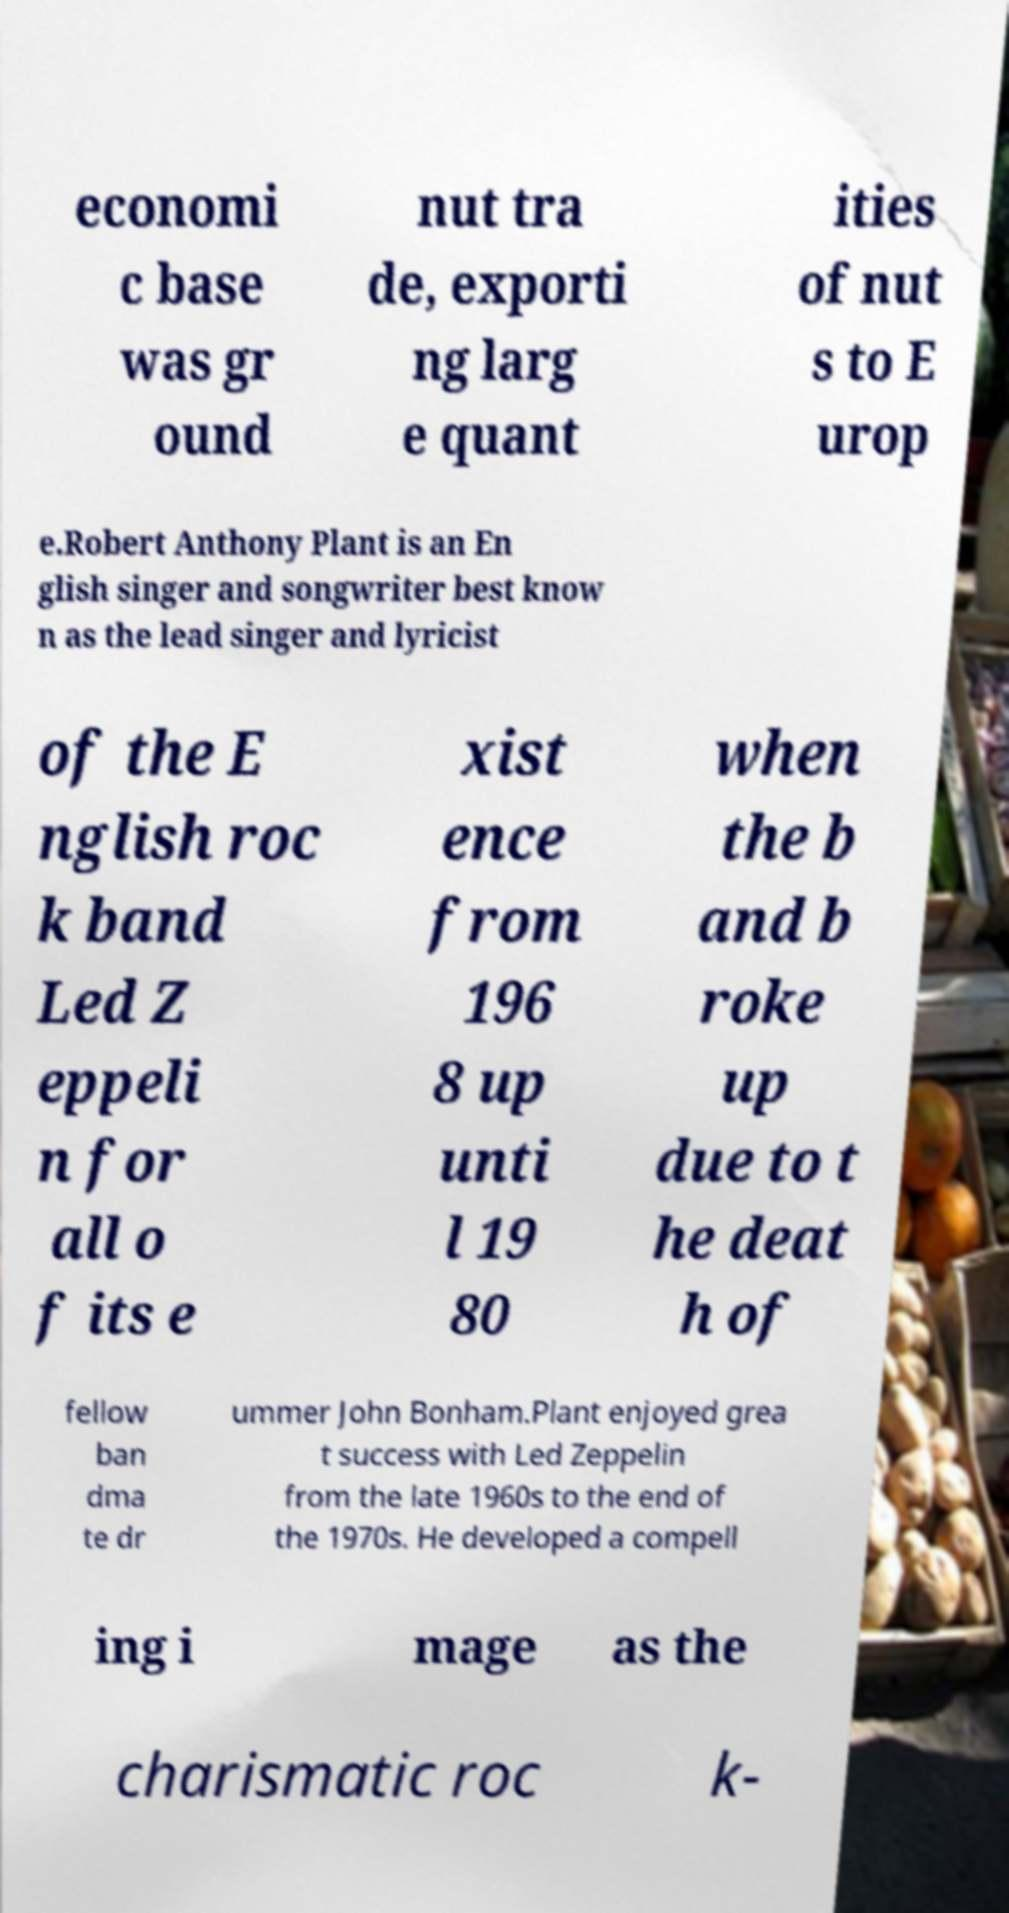Please identify and transcribe the text found in this image. economi c base was gr ound nut tra de, exporti ng larg e quant ities of nut s to E urop e.Robert Anthony Plant is an En glish singer and songwriter best know n as the lead singer and lyricist of the E nglish roc k band Led Z eppeli n for all o f its e xist ence from 196 8 up unti l 19 80 when the b and b roke up due to t he deat h of fellow ban dma te dr ummer John Bonham.Plant enjoyed grea t success with Led Zeppelin from the late 1960s to the end of the 1970s. He developed a compell ing i mage as the charismatic roc k- 